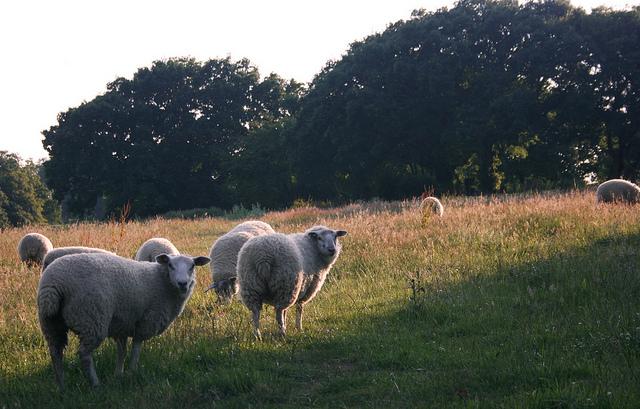Are the animals grazing?
Concise answer only. Yes. Why is the sheep have a blue mark on its back?
Be succinct. No blue mark. What color is the dry grass?
Keep it brief. Brown. Are the trees bare?
Quick response, please. No. What are the sheep doing?
Write a very short answer. Looking at camera. Are the sheep facing the viewer?
Quick response, please. Yes. Are all the sheep looking at the photographer?
Keep it brief. No. What do these animals eat?
Short answer required. Grass. What is the weather?
Write a very short answer. Sunny. Are some of these baby animals?
Concise answer only. No. Is the weather overcast?
Keep it brief. No. How many elephants are shown?
Quick response, please. 0. What season is it?
Quick response, please. Summer. 